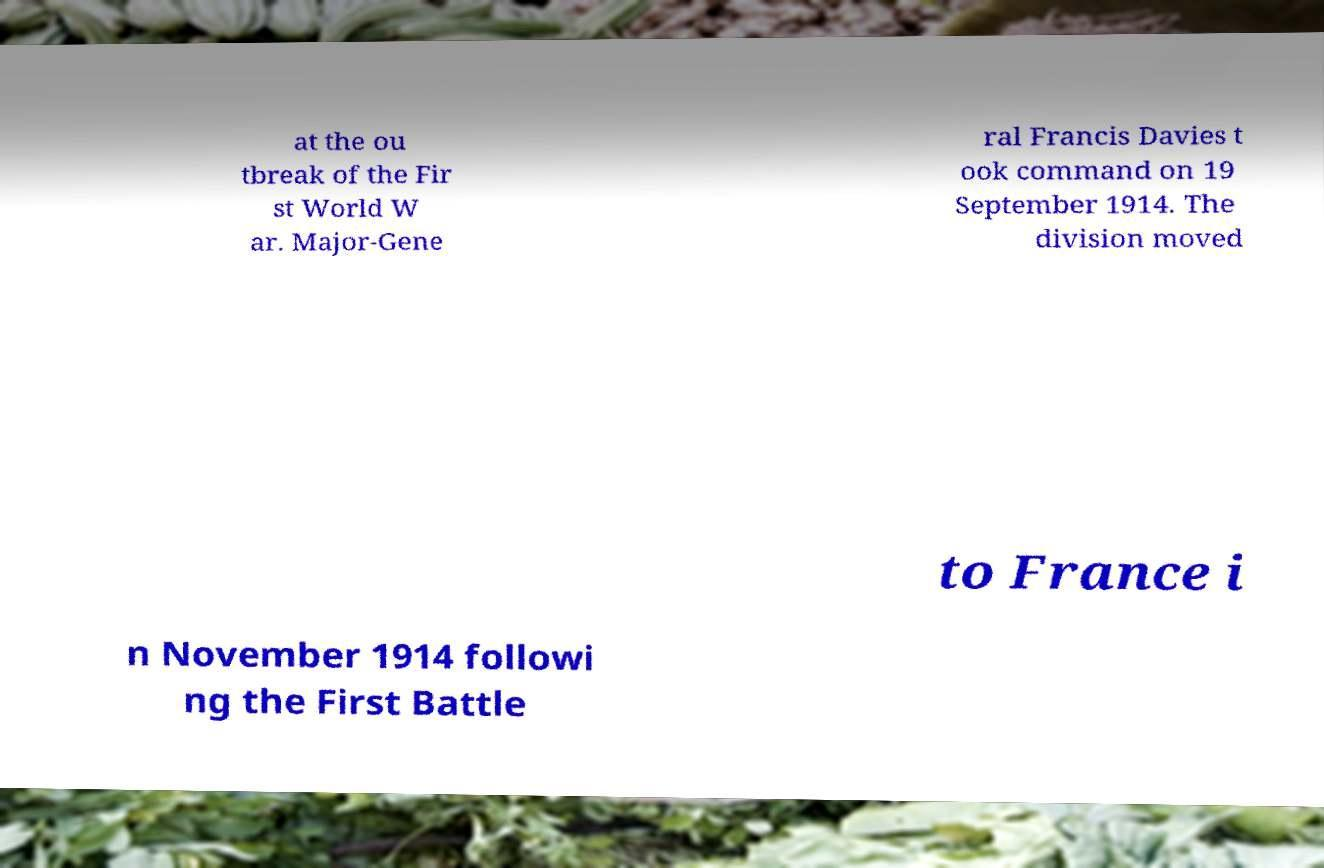For documentation purposes, I need the text within this image transcribed. Could you provide that? at the ou tbreak of the Fir st World W ar. Major-Gene ral Francis Davies t ook command on 19 September 1914. The division moved to France i n November 1914 followi ng the First Battle 